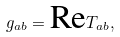<formula> <loc_0><loc_0><loc_500><loc_500>g _ { a b } = \text {Re} T _ { a b } ,</formula> 